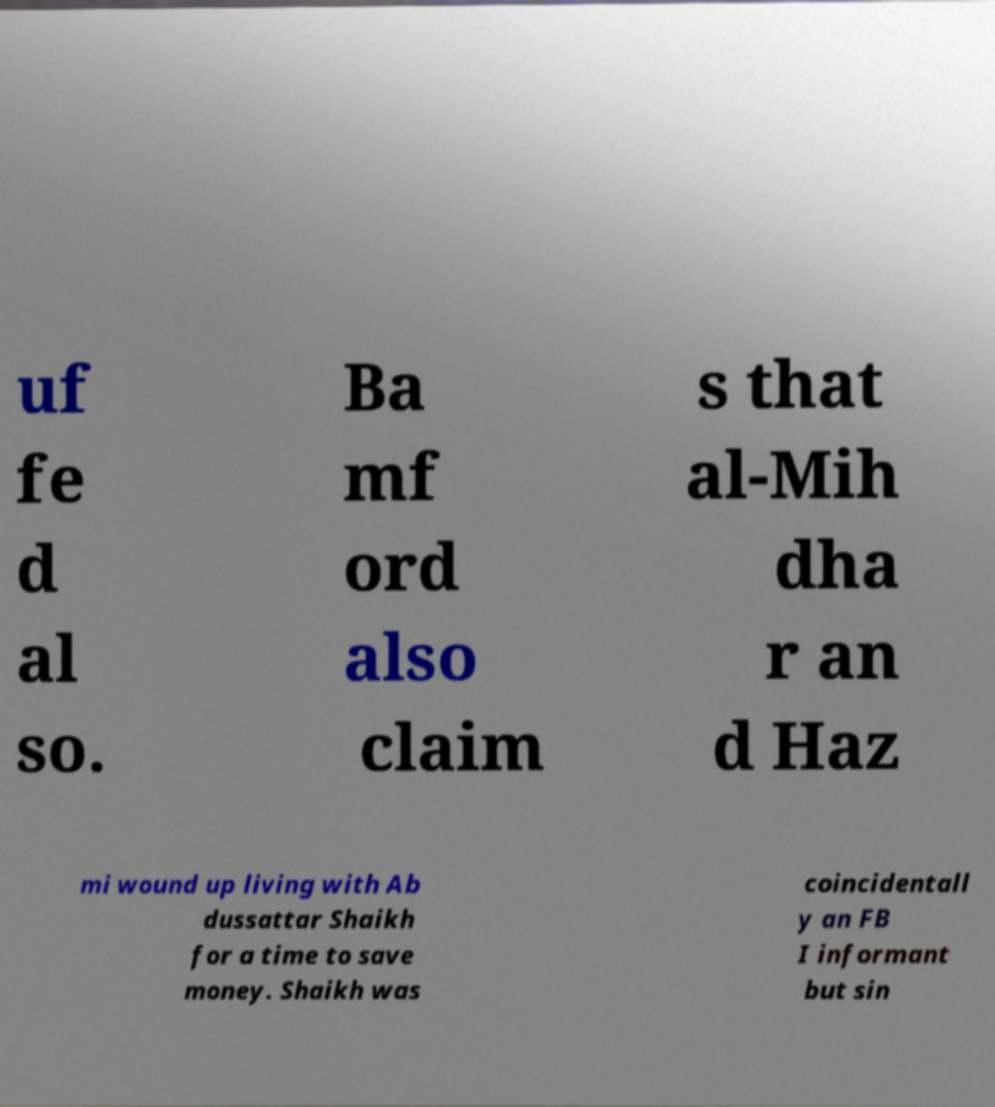Can you accurately transcribe the text from the provided image for me? uf fe d al so. Ba mf ord also claim s that al-Mih dha r an d Haz mi wound up living with Ab dussattar Shaikh for a time to save money. Shaikh was coincidentall y an FB I informant but sin 